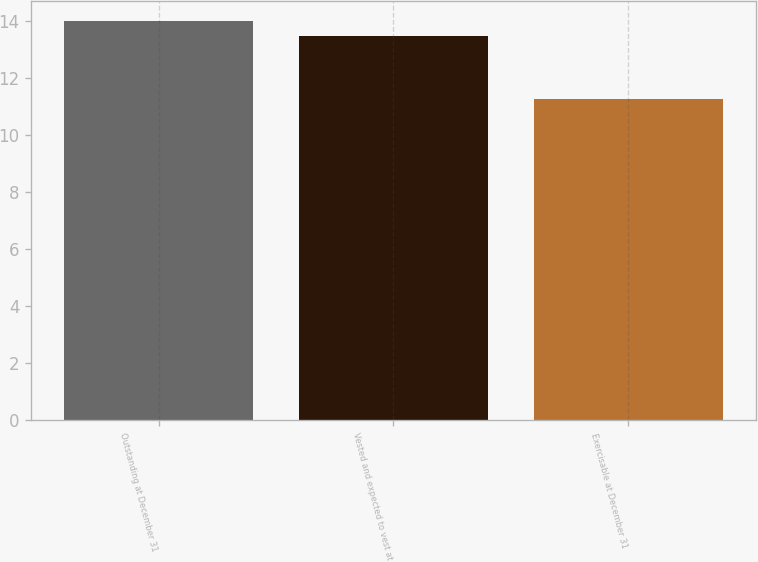<chart> <loc_0><loc_0><loc_500><loc_500><bar_chart><fcel>Outstanding at December 31<fcel>Vested and expected to vest at<fcel>Exercisable at December 31<nl><fcel>14.02<fcel>13.48<fcel>11.29<nl></chart> 